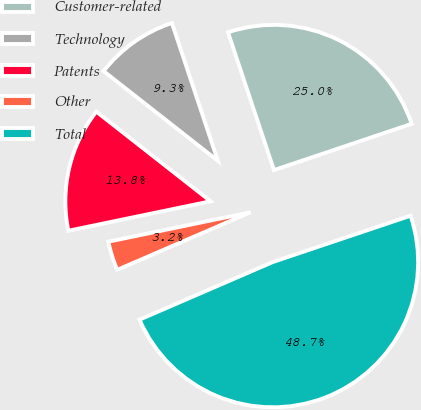Convert chart to OTSL. <chart><loc_0><loc_0><loc_500><loc_500><pie_chart><fcel>Customer-related<fcel>Technology<fcel>Patents<fcel>Other<fcel>Total<nl><fcel>24.96%<fcel>9.29%<fcel>13.84%<fcel>3.24%<fcel>48.67%<nl></chart> 